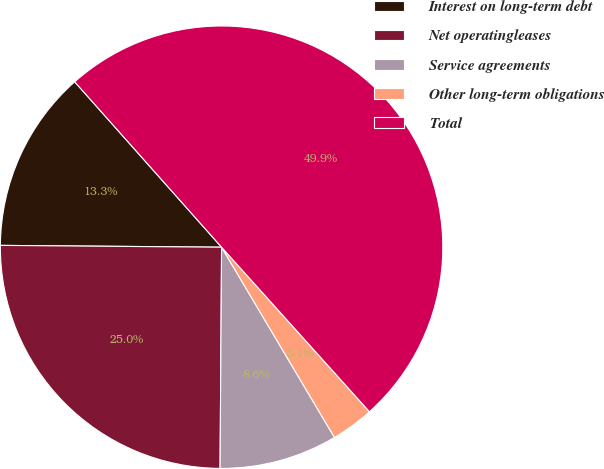Convert chart to OTSL. <chart><loc_0><loc_0><loc_500><loc_500><pie_chart><fcel>Interest on long-term debt<fcel>Net operatingleases<fcel>Service agreements<fcel>Other long-term obligations<fcel>Total<nl><fcel>13.31%<fcel>25.02%<fcel>8.63%<fcel>3.13%<fcel>49.9%<nl></chart> 